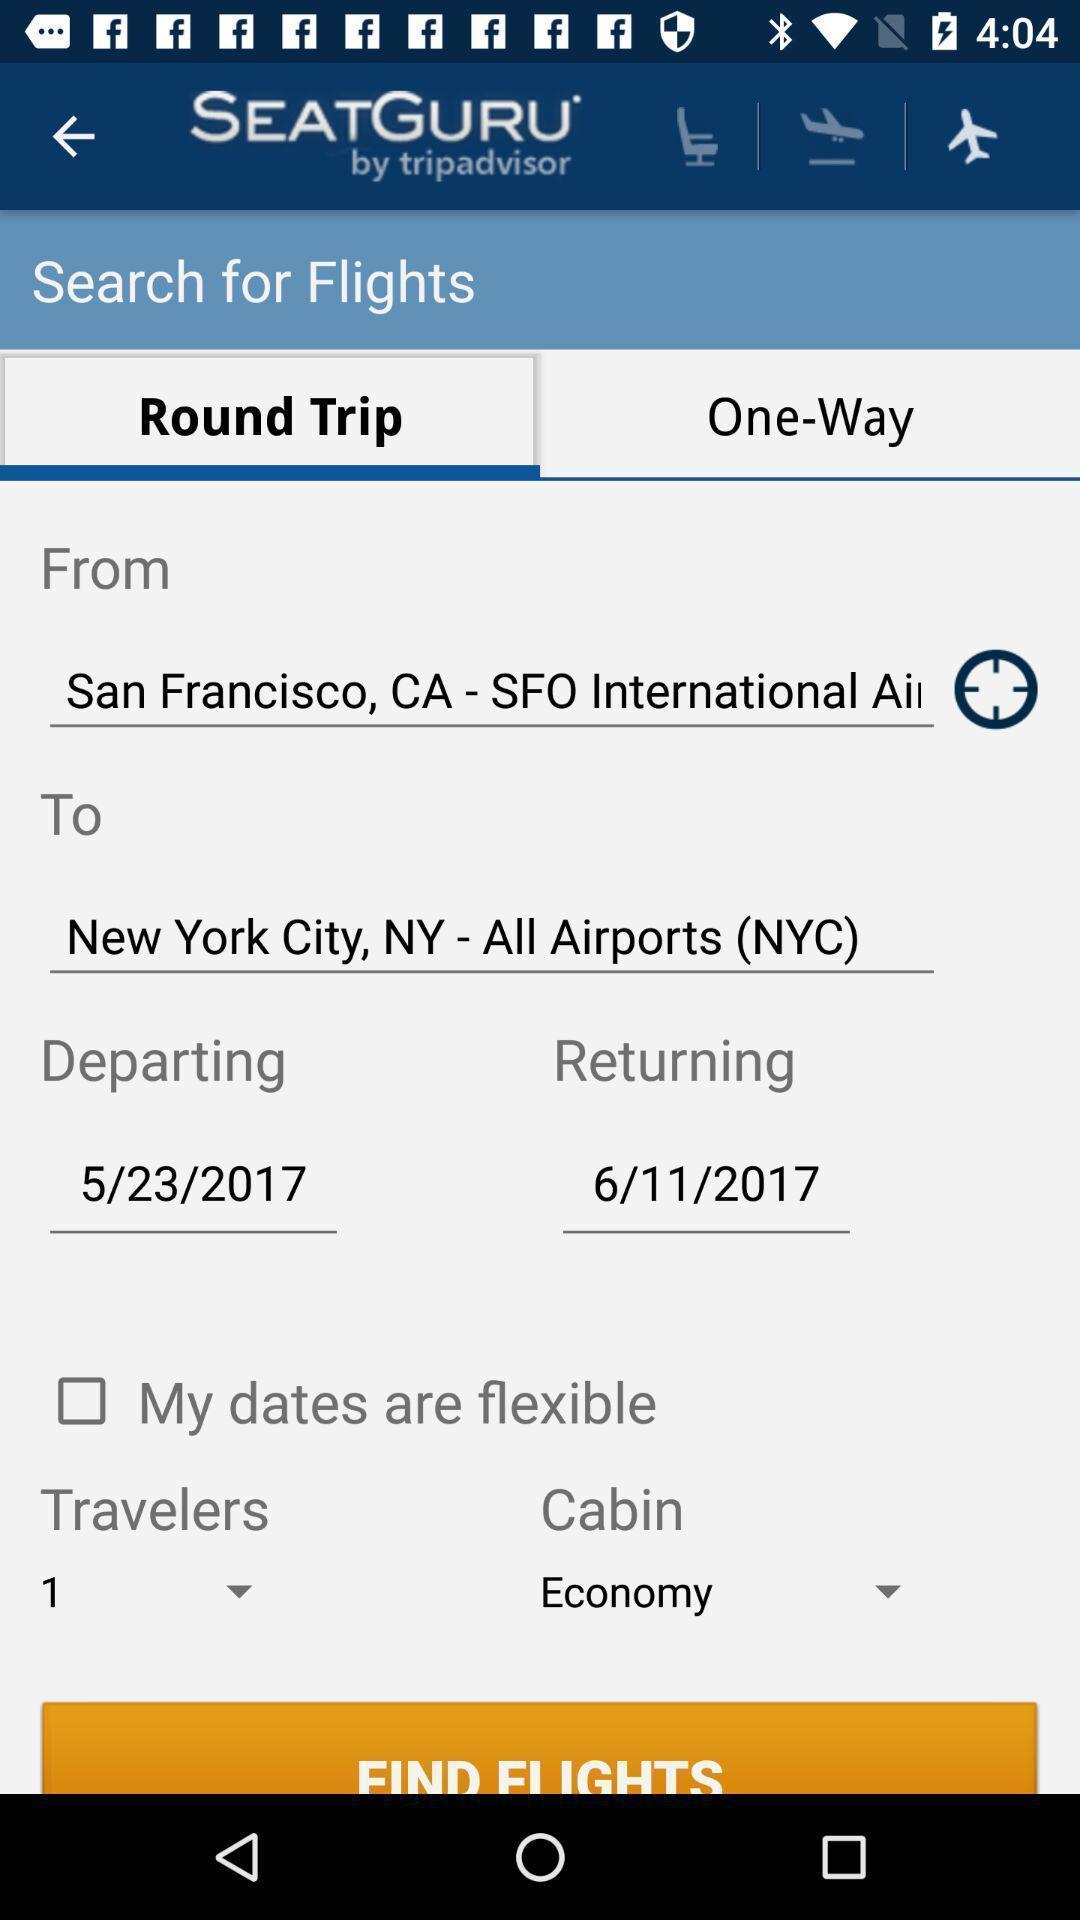What can you discern from this picture? Search bar for searching the flights in travelling application. 